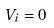<formula> <loc_0><loc_0><loc_500><loc_500>V _ { i } = 0</formula> 